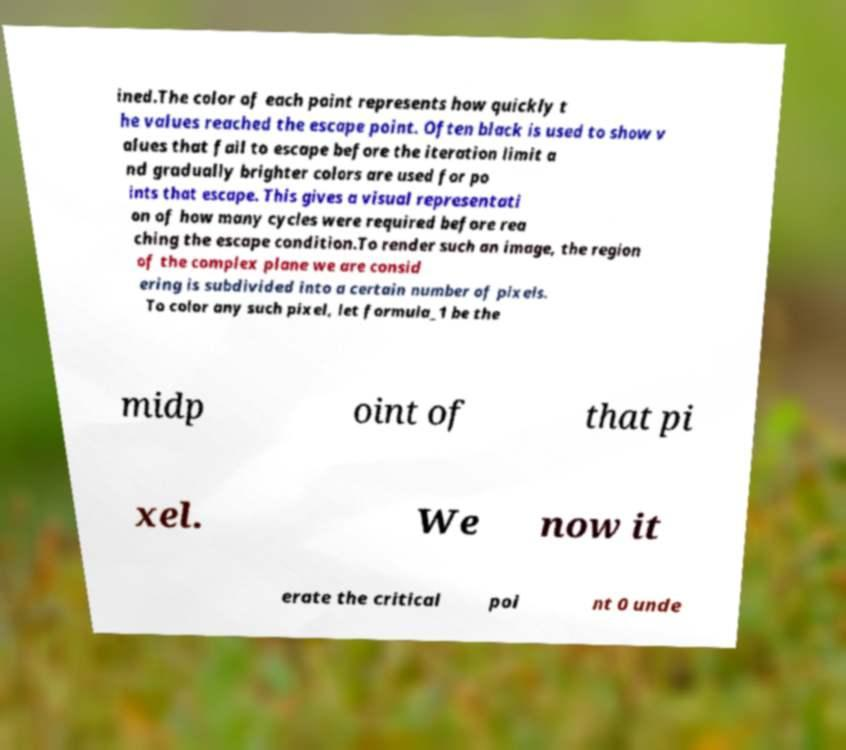Could you extract and type out the text from this image? ined.The color of each point represents how quickly t he values reached the escape point. Often black is used to show v alues that fail to escape before the iteration limit a nd gradually brighter colors are used for po ints that escape. This gives a visual representati on of how many cycles were required before rea ching the escape condition.To render such an image, the region of the complex plane we are consid ering is subdivided into a certain number of pixels. To color any such pixel, let formula_1 be the midp oint of that pi xel. We now it erate the critical poi nt 0 unde 